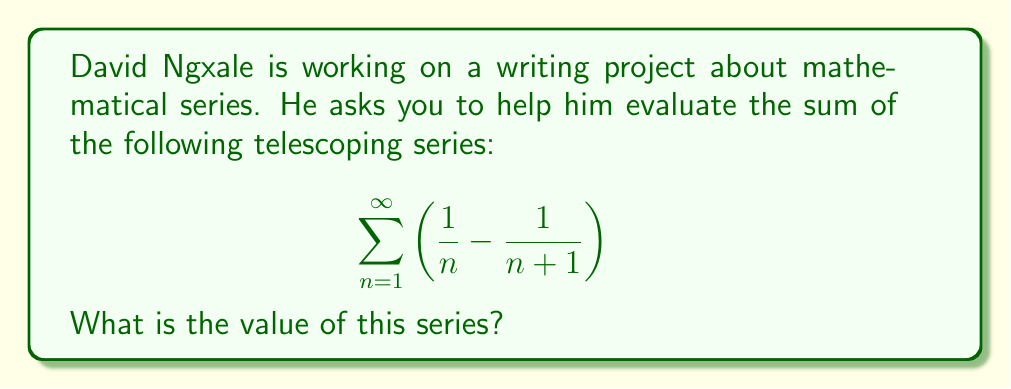Provide a solution to this math problem. Let's approach this step-by-step:

1) First, let's write out the first few terms of the series to observe the pattern:

   $\left(\frac{1}{1} - \frac{1}{2}\right) + \left(\frac{1}{2} - \frac{1}{3}\right) + \left(\frac{1}{3} - \frac{1}{4}\right) + \left(\frac{1}{4} - \frac{1}{5}\right) + ...$

2) We can see that the series is telescoping, meaning that each term after the first $\frac{1}{1}$ cancels out with a part of the next term.

3) Let's write out the partial sum $S_n$ for the first n terms:

   $S_n = \left(\frac{1}{1} - \frac{1}{2}\right) + \left(\frac{1}{2} - \frac{1}{3}\right) + ... + \left(\frac{1}{n} - \frac{1}{n+1}\right)$

4) Cancelling out the terms that appear both positively and negatively, we get:

   $S_n = 1 - \frac{1}{n+1}$

5) To find the sum of the infinite series, we need to take the limit as n approaches infinity:

   $\lim_{n \to \infty} S_n = \lim_{n \to \infty} \left(1 - \frac{1}{n+1}\right)$

6) As n approaches infinity, $\frac{1}{n+1}$ approaches 0, so:

   $\lim_{n \to \infty} S_n = 1 - 0 = 1$

Therefore, the sum of the infinite series is 1.
Answer: 1 